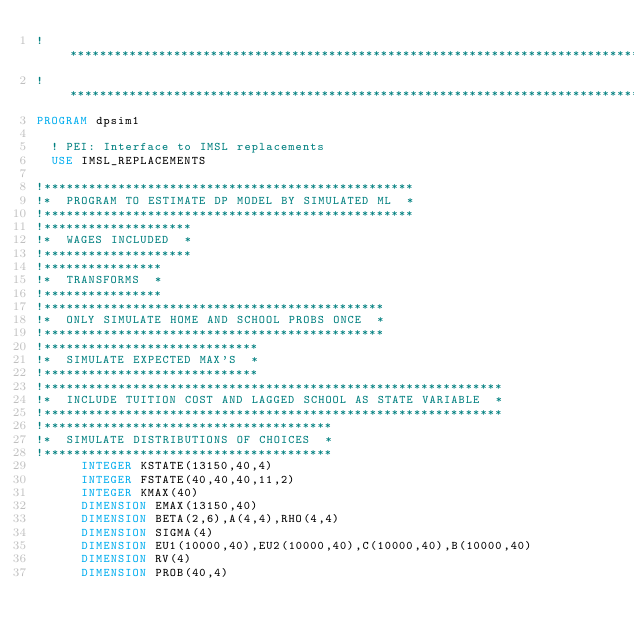<code> <loc_0><loc_0><loc_500><loc_500><_FORTRAN_>!*******************************************************************************
!*******************************************************************************
PROGRAM dpsim1

  ! PEI: Interface to IMSL replacements
  USE IMSL_REPLACEMENTS
  
!**************************************************
!*  PROGRAM TO ESTIMATE DP MODEL BY SIMULATED ML  *
!**************************************************
!********************
!*  WAGES INCLUDED  *
!********************
!****************
!*  TRANSFORMS  *
!****************
!**********************************************
!*  ONLY SIMULATE HOME AND SCHOOL PROBS ONCE  *
!**********************************************
!*****************************
!*  SIMULATE EXPECTED MAX'S  *
!*****************************
!**************************************************************
!*  INCLUDE TUITION COST AND LAGGED SCHOOL AS STATE VARIABLE  *
!**************************************************************
!***************************************
!*  SIMULATE DISTRIBUTIONS OF CHOICES  *
!***************************************
      INTEGER KSTATE(13150,40,4)
      INTEGER FSTATE(40,40,40,11,2)
      INTEGER KMAX(40)
      DIMENSION EMAX(13150,40)
      DIMENSION BETA(2,6),A(4,4),RHO(4,4)
      DIMENSION SIGMA(4)
      DIMENSION EU1(10000,40),EU2(10000,40),C(10000,40),B(10000,40)
      DIMENSION RV(4)
      DIMENSION PROB(40,4)</code> 